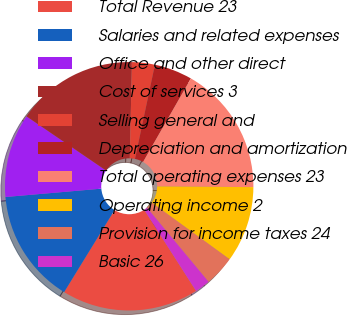Convert chart. <chart><loc_0><loc_0><loc_500><loc_500><pie_chart><fcel>Total Revenue 23<fcel>Salaries and related expenses<fcel>Office and other direct<fcel>Cost of services 3<fcel>Selling general and<fcel>Depreciation and amortization<fcel>Total operating expenses 23<fcel>Operating income 2<fcel>Provision for income taxes 24<fcel>Basic 26<nl><fcel>17.82%<fcel>14.85%<fcel>10.89%<fcel>15.84%<fcel>2.97%<fcel>4.95%<fcel>16.83%<fcel>9.9%<fcel>3.96%<fcel>1.98%<nl></chart> 